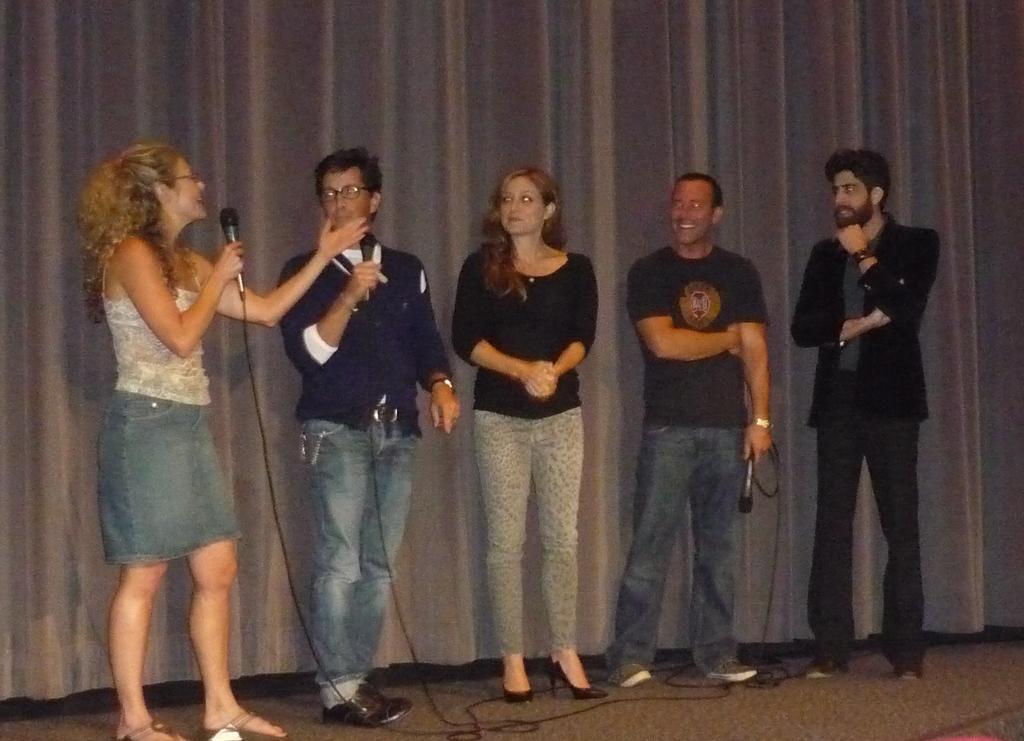Could you give a brief overview of what you see in this image? In this image I can see the stage, few wires and few persons standing on the stage. I can see two of them are holding microphones in their hands. In the background I can see the curtain. 